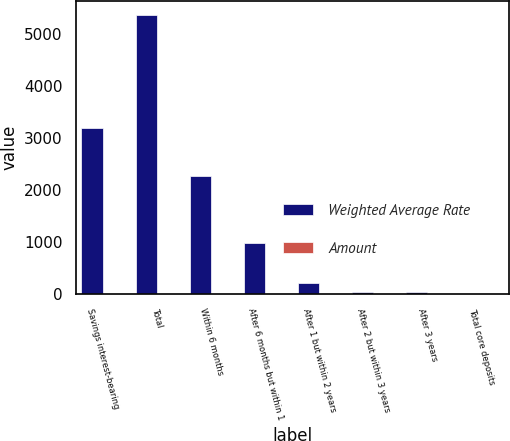Convert chart. <chart><loc_0><loc_0><loc_500><loc_500><stacked_bar_chart><ecel><fcel>Savings interest-bearing<fcel>Total<fcel>Within 6 months<fcel>After 6 months but within 1<fcel>After 1 but within 2 years<fcel>After 2 but within 3 years<fcel>After 3 years<fcel>Total core deposits<nl><fcel>Weighted Average Rate<fcel>3192<fcel>5380.1<fcel>2282.7<fcel>980.2<fcel>220.8<fcel>45.4<fcel>49.2<fcel>4.63<nl><fcel>Amount<fcel>1.39<fcel>0.82<fcel>4.5<fcel>4.63<fcel>3.65<fcel>3.14<fcel>4.63<fcel>2.28<nl></chart> 